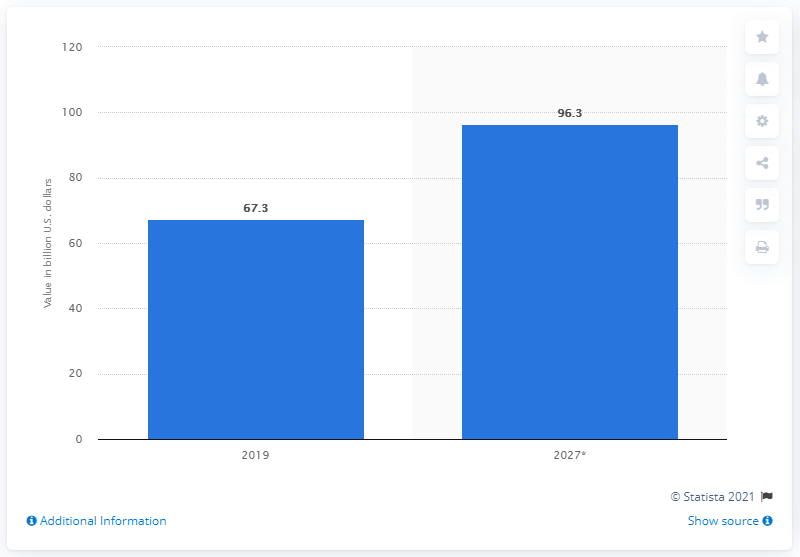Highlight a few significant elements in this photo. In 2019, the global baby food market was valued at approximately 67.3 billion dollars. 